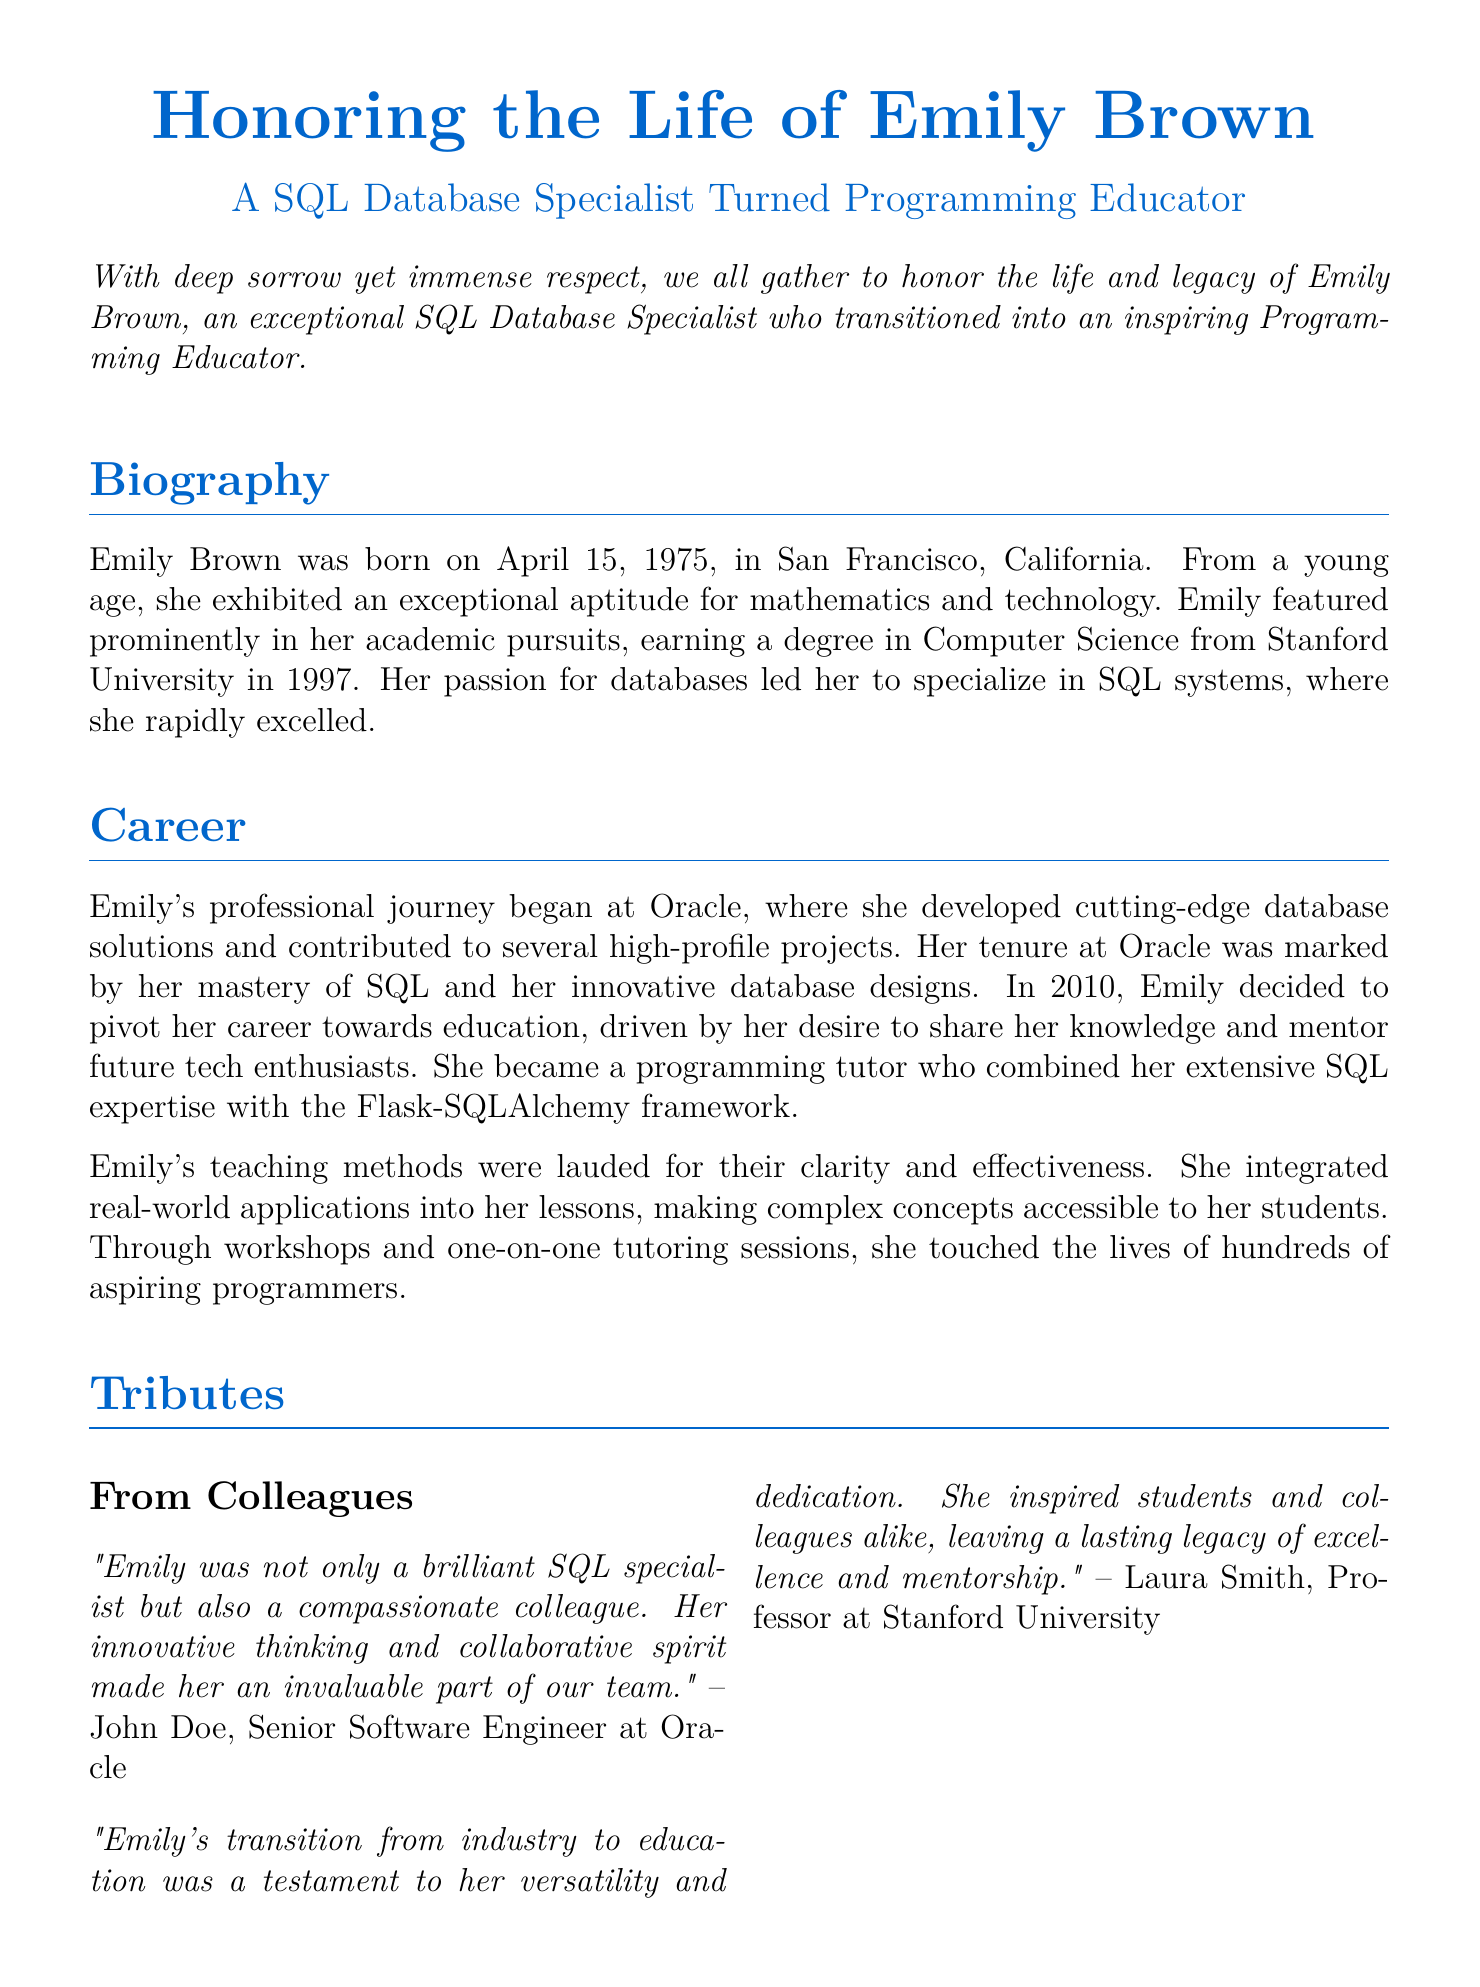What was Emily Brown's profession before becoming an educator? Emily Brown was a SQL Database Specialist before transitioning into education.
Answer: SQL Database Specialist In which university did Emily earn her degree? Emily earned her degree in Computer Science from Stanford University.
Answer: Stanford University What is Emily Brown's birthdate? Emily was born on April 15, 1975.
Answer: April 15, 1975 What role did John Doe hold? John Doe is described as a Senior Software Engineer at Oracle.
Answer: Senior Software Engineer Which framework did Emily incorporate into her teaching? Emily combined her SQL expertise with the Flask-SQLAlchemy framework in her teaching.
Answer: Flask-SQLAlchemy What city was Emily Brown born in? Emily was born in San Francisco, California.
Answer: San Francisco What was a key trait of Emily's teaching methods? Emily's teaching methods were lauded for their clarity and effectiveness.
Answer: Clarity and effectiveness Who expressed admiration for Emily's versatility? Laura Smith, a Professor at Stanford University, expressed admiration for Emily's versatility.
Answer: Laura Smith What is mentioned as Emily's legacy? Emily's legacy includes her unparalleled expertise and passion for teaching.
Answer: Unparalleled expertise and passion for teaching 